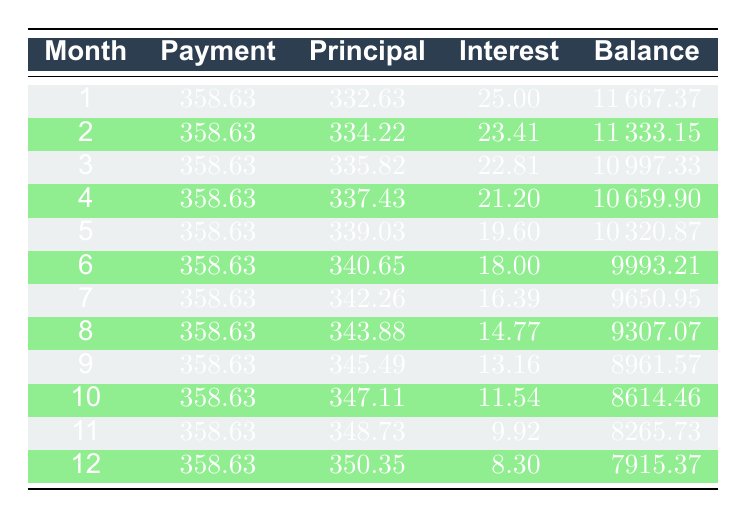What is the total amount of interest paid in the first 12 months? To find the total interest paid in the first 12 months, sum the interest values from each month. The sums are: 25.00 + 23.41 + 22.81 + 21.20 + 19.60 + 18.00 + 16.39 + 14.77 + 13.16 + 11.54 + 9.92 + 8.30 =  302.60
Answer: 302.60 What is the remaining balance after the 6th month? The remaining balance after the 6th month can be found directly in the table under the "Balance" column for month 6, which is listed as 9993.21.
Answer: 9993.21 How much principal is paid in month 10? The principal paid in month 10 is given directly in the table and is listed under the "Principal" column for month 10, which is 347.11.
Answer: 347.11 Is the payment amount the same for all months? Looking at the "Payment" column for each month, the payment amount of 358.63 is consistent throughout all 12 months. Therefore, yes, the payment amount is the same.
Answer: Yes What is the average principal payment made over the first 12 months? The average principal payment is calculated by summing all the principal payments from each month and dividing by the number of payments. Sum: (332.63 + 334.22 + 335.82 + 337.43 + 339.03 + 340.65 + 342.26 + 343.88 + 345.49 + 347.11 + 348.73 + 350.35) = 4,086.41. Then divide by 12: 4086.41 / 12 = 340.53.
Answer: 340.53 What is the change in the remaining balance from the end of month 1 to the end of month 5? The remaining balance at the end of month 1 is 11667.37 and at the end of month 5 is 10320.87. The change is calculated as 10320.87 - 11667.37 = -1346.50. This means the balance decreased by 1346.50.
Answer: -1346.50 Which month has the lowest interest payment, and what is that amount? The interest payment decreases each month. By reviewing the "Interest" column, the lowest interest payment is found in month 12, which is 8.30.
Answer: Month 12, 8.30 What is the total payment made over the first 12 months? The total payment is calculated by multiplying the monthly payment amount by the number of months: 358.63 * 12 = 4303.56.
Answer: 4303.56 